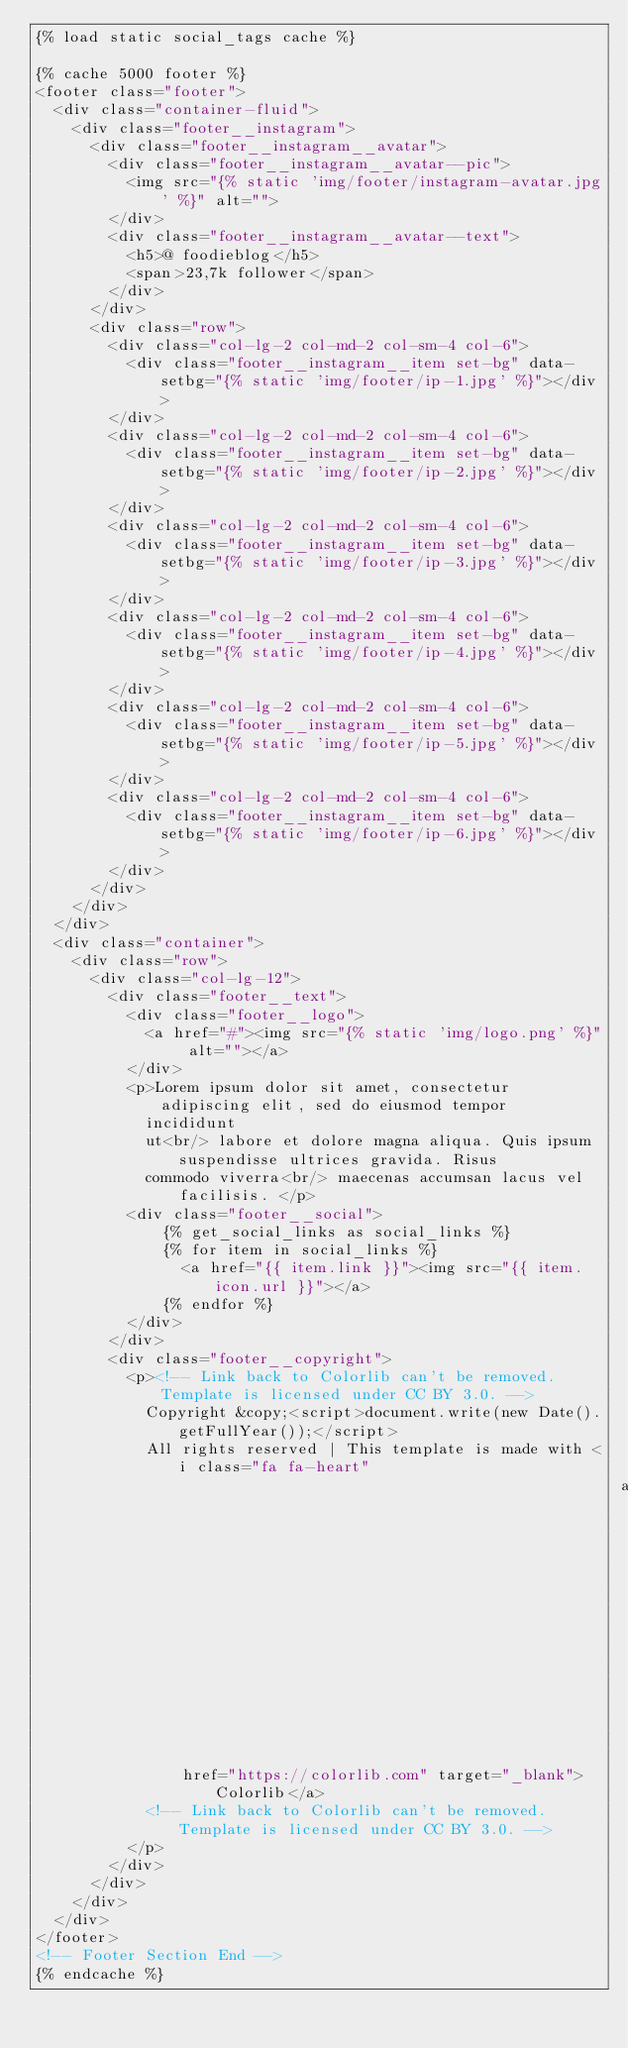Convert code to text. <code><loc_0><loc_0><loc_500><loc_500><_HTML_>{% load static social_tags cache %}

{% cache 5000 footer %}
<footer class="footer">
  <div class="container-fluid">
    <div class="footer__instagram">
      <div class="footer__instagram__avatar">
        <div class="footer__instagram__avatar--pic">
          <img src="{% static 'img/footer/instagram-avatar.jpg' %}" alt="">
        </div>
        <div class="footer__instagram__avatar--text">
          <h5>@ foodieblog</h5>
          <span>23,7k follower</span>
        </div>
      </div>
      <div class="row">
        <div class="col-lg-2 col-md-2 col-sm-4 col-6">
          <div class="footer__instagram__item set-bg" data-setbg="{% static 'img/footer/ip-1.jpg' %}"></div>
        </div>
        <div class="col-lg-2 col-md-2 col-sm-4 col-6">
          <div class="footer__instagram__item set-bg" data-setbg="{% static 'img/footer/ip-2.jpg' %}"></div>
        </div>
        <div class="col-lg-2 col-md-2 col-sm-4 col-6">
          <div class="footer__instagram__item set-bg" data-setbg="{% static 'img/footer/ip-3.jpg' %}"></div>
        </div>
        <div class="col-lg-2 col-md-2 col-sm-4 col-6">
          <div class="footer__instagram__item set-bg" data-setbg="{% static 'img/footer/ip-4.jpg' %}"></div>
        </div>
        <div class="col-lg-2 col-md-2 col-sm-4 col-6">
          <div class="footer__instagram__item set-bg" data-setbg="{% static 'img/footer/ip-5.jpg' %}"></div>
        </div>
        <div class="col-lg-2 col-md-2 col-sm-4 col-6">
          <div class="footer__instagram__item set-bg" data-setbg="{% static 'img/footer/ip-6.jpg' %}"></div>
        </div>
      </div>
    </div>
  </div>
  <div class="container">
    <div class="row">
      <div class="col-lg-12">
        <div class="footer__text">
          <div class="footer__logo">
            <a href="#"><img src="{% static 'img/logo.png' %}" alt=""></a>
          </div>
          <p>Lorem ipsum dolor sit amet, consectetur adipiscing elit, sed do eiusmod tempor
            incididunt
            ut<br/> labore et dolore magna aliqua. Quis ipsum suspendisse ultrices gravida. Risus
            commodo viverra<br/> maecenas accumsan lacus vel facilisis. </p>
          <div class="footer__social">
              {% get_social_links as social_links %}
              {% for item in social_links %}
                <a href="{{ item.link }}"><img src="{{ item.icon.url }}"></a>
              {% endfor %}
          </div>
        </div>
        <div class="footer__copyright">
          <p><!-- Link back to Colorlib can't be removed. Template is licensed under CC BY 3.0. -->
            Copyright &copy;<script>document.write(new Date().getFullYear());</script>
            All rights reserved | This template is made with <i class="fa fa-heart"
                                                                aria-hidden="true"></i> by <a
                href="https://colorlib.com" target="_blank">Colorlib</a>
            <!-- Link back to Colorlib can't be removed. Template is licensed under CC BY 3.0. -->
          </p>
        </div>
      </div>
    </div>
  </div>
</footer>
<!-- Footer Section End -->
{% endcache %}
</code> 